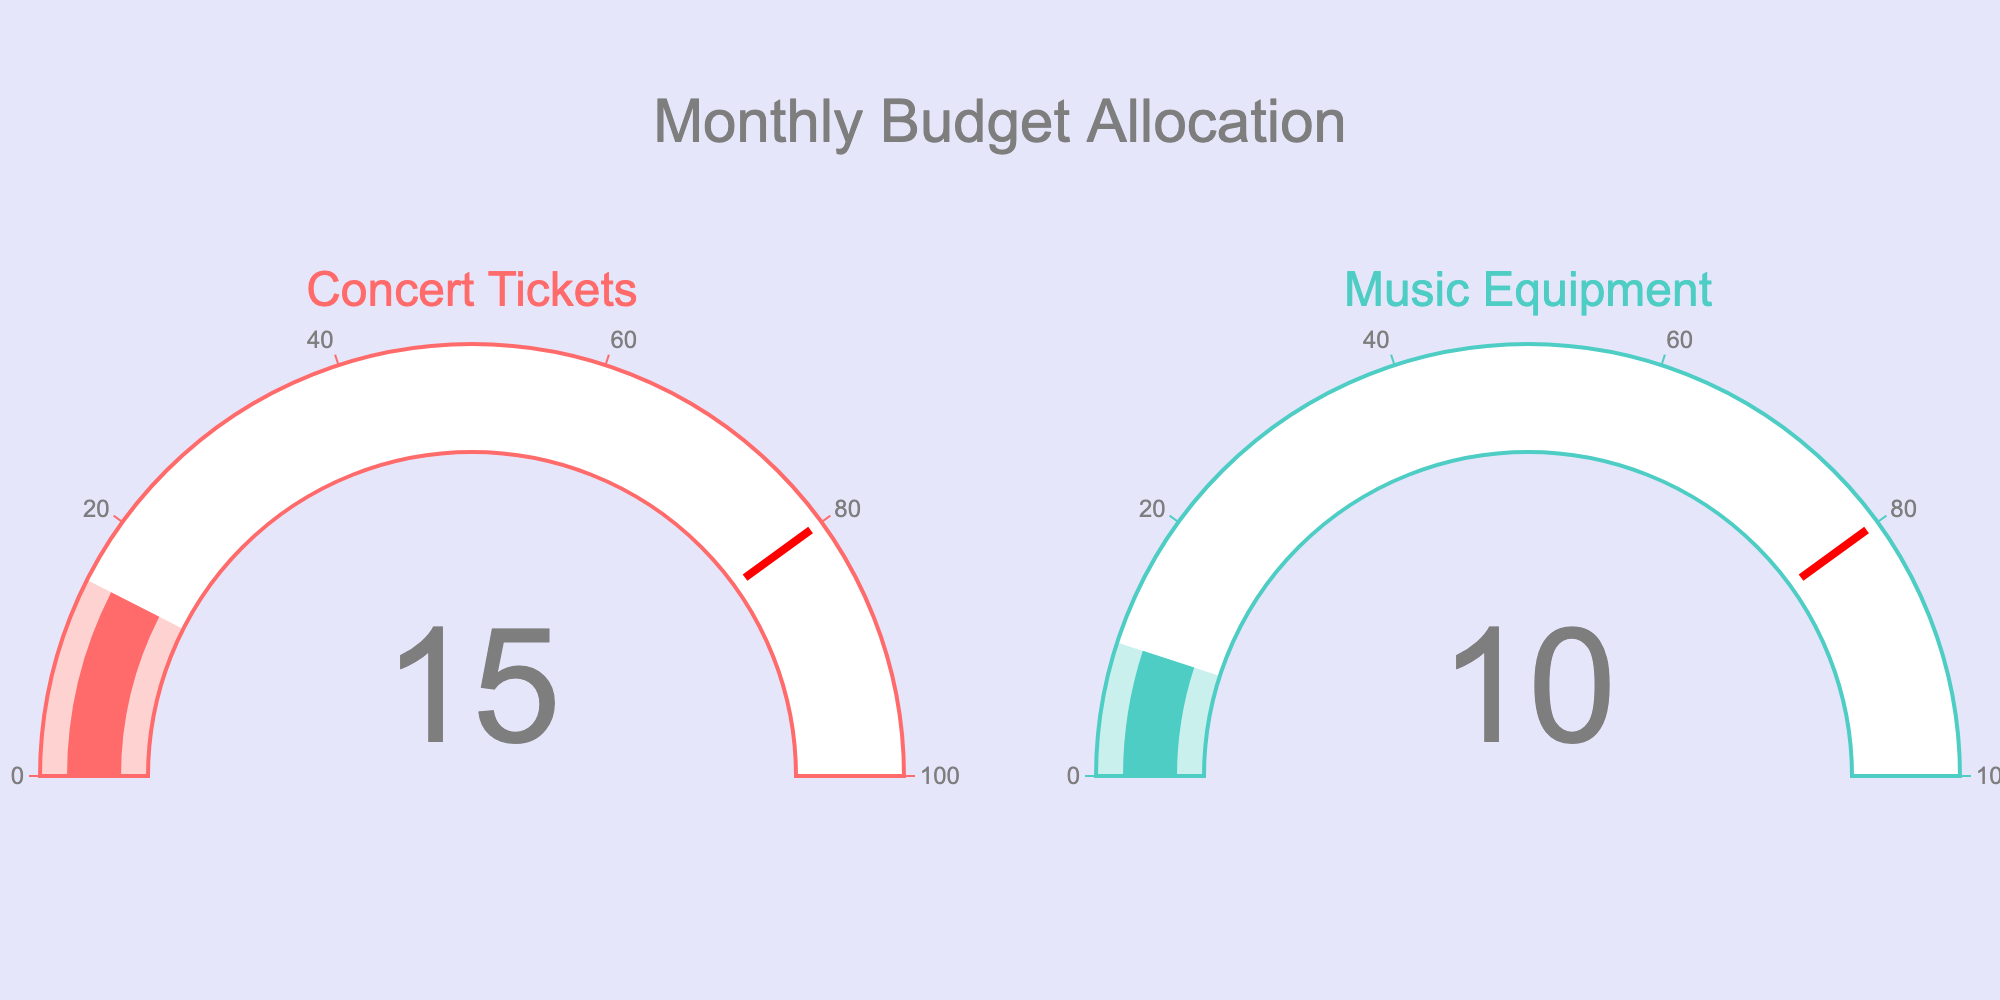What's the title of the figure? The title of the figure is usually found at the top and is meant to describe the chart's purpose or data. Here, the title is "Monthly Budget Allocation."
Answer: Monthly Budget Allocation How many categories are shown in the figure? By looking at the number of gauges, which are labeled with their respective categories, we can count that there are two categories shown.
Answer: 2 Which category has the highest percentage allocated from the budget? To find the highest percentage, we compare the values shown on the gauges for both categories. The gauge for "Concert Tickets" shows 15%, which is higher than the 10% for "Music Equipment."
Answer: Concert Tickets What's the sum of the percentages allocated to concert tickets and music equipment? To find the total percentage allocated to both categories, we add up the individual percentages: 15% for concert tickets and 10% for music equipment. The sum is 15% + 10% = 25%.
Answer: 25% Is the percentage allocated to concert tickets greater than that allocated to music equipment? We compare the two percentages, 15% for concert tickets and 10% for music equipment. Since 15% is greater than 10%, the answer is yes.
Answer: Yes What percentage is allocated to music equipment? The percentage for music equipment is directly shown on its respective gauge, which reads 10%.
Answer: 10% What is the difference in the percentage allocation between concert tickets and music equipment? To find the difference between the two percentages, subtract the smaller percentage (10%) from the larger one (15%): 15% - 10% = 5%.
Answer: 5% If the total monthly budget is $1000, how much is allocated to concert tickets? If 15% of the monthly budget is allocated to concert tickets, we calculate 15% of $1000: (15/100) * 1000 = $150.
Answer: $150 How much more is allocated to concert tickets compared to music equipment in terms of percentage? The difference in allocation percentages between concert tickets (15%) and music equipment (10%) can be found by subtracting the two: 15% - 10% = 5%. Therefore, 5% more is allocated to concert tickets.
Answer: 5% 